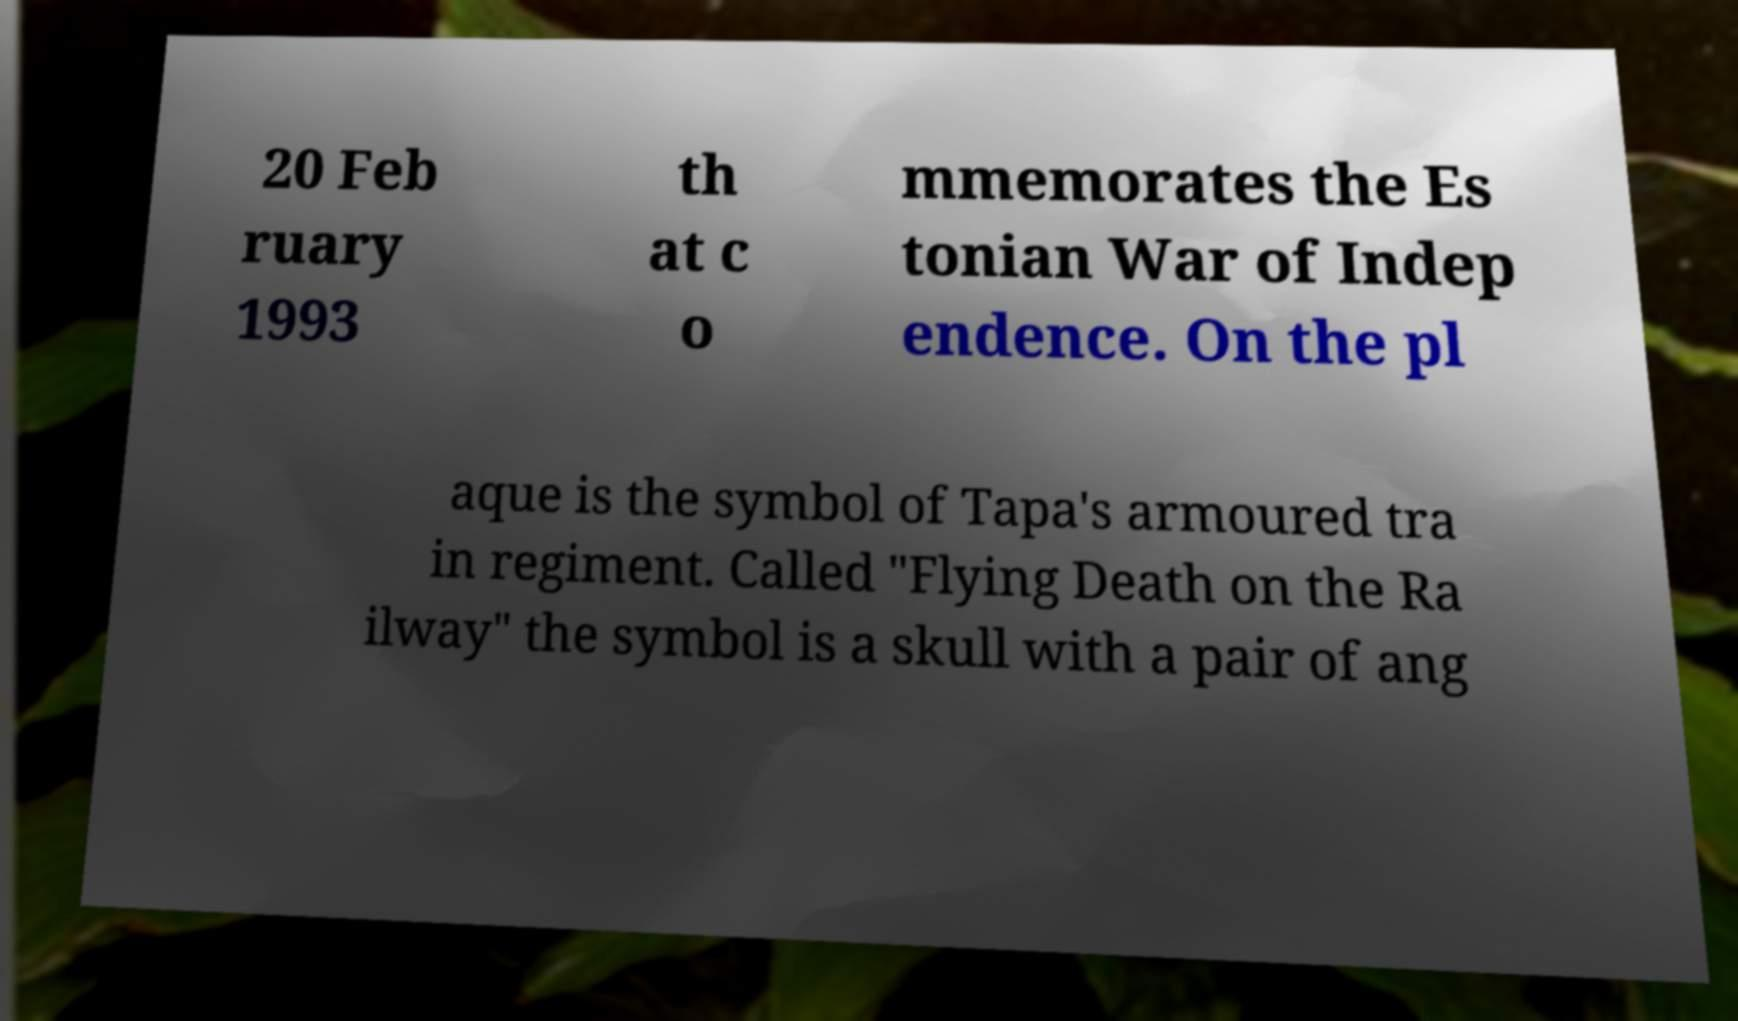I need the written content from this picture converted into text. Can you do that? 20 Feb ruary 1993 th at c o mmemorates the Es tonian War of Indep endence. On the pl aque is the symbol of Tapa's armoured tra in regiment. Called "Flying Death on the Ra ilway" the symbol is a skull with a pair of ang 